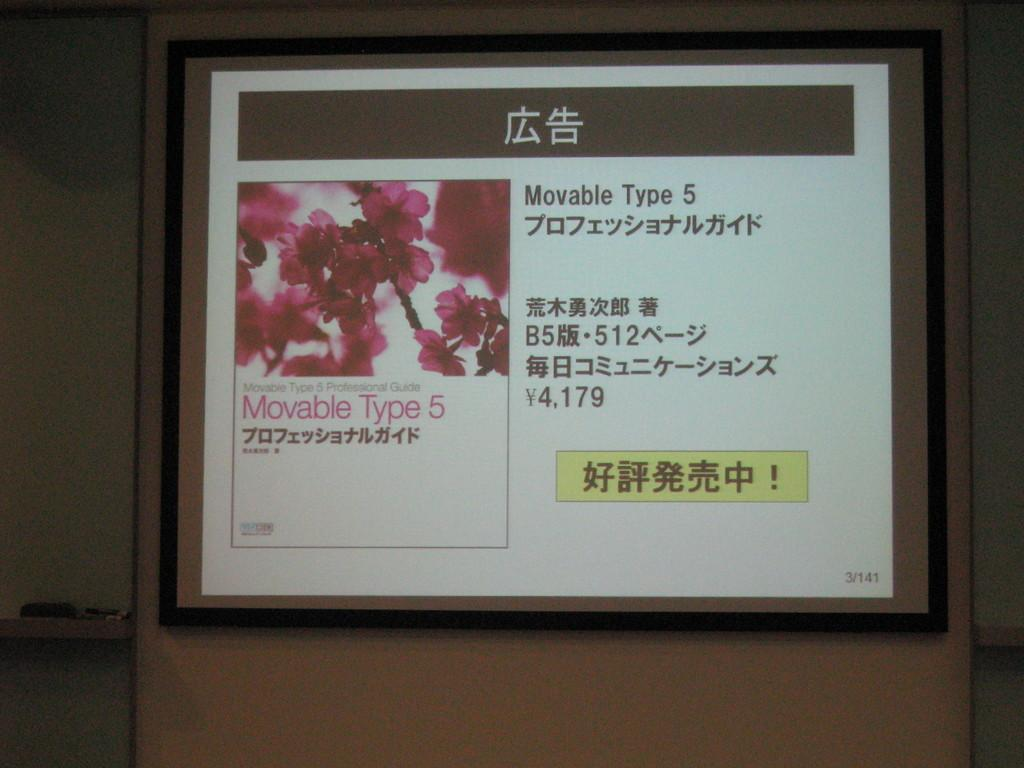What is the main object in the image? There is a screen in the image. What is shown on the screen? The screen displays a picture of flowers. Is there any text visible on the screen? Yes, there is some text visible on the screen. Can you see any seashore in the image? There is no seashore present in the image. Is there a yoke visible in the image? There is no yoke present in the image. 